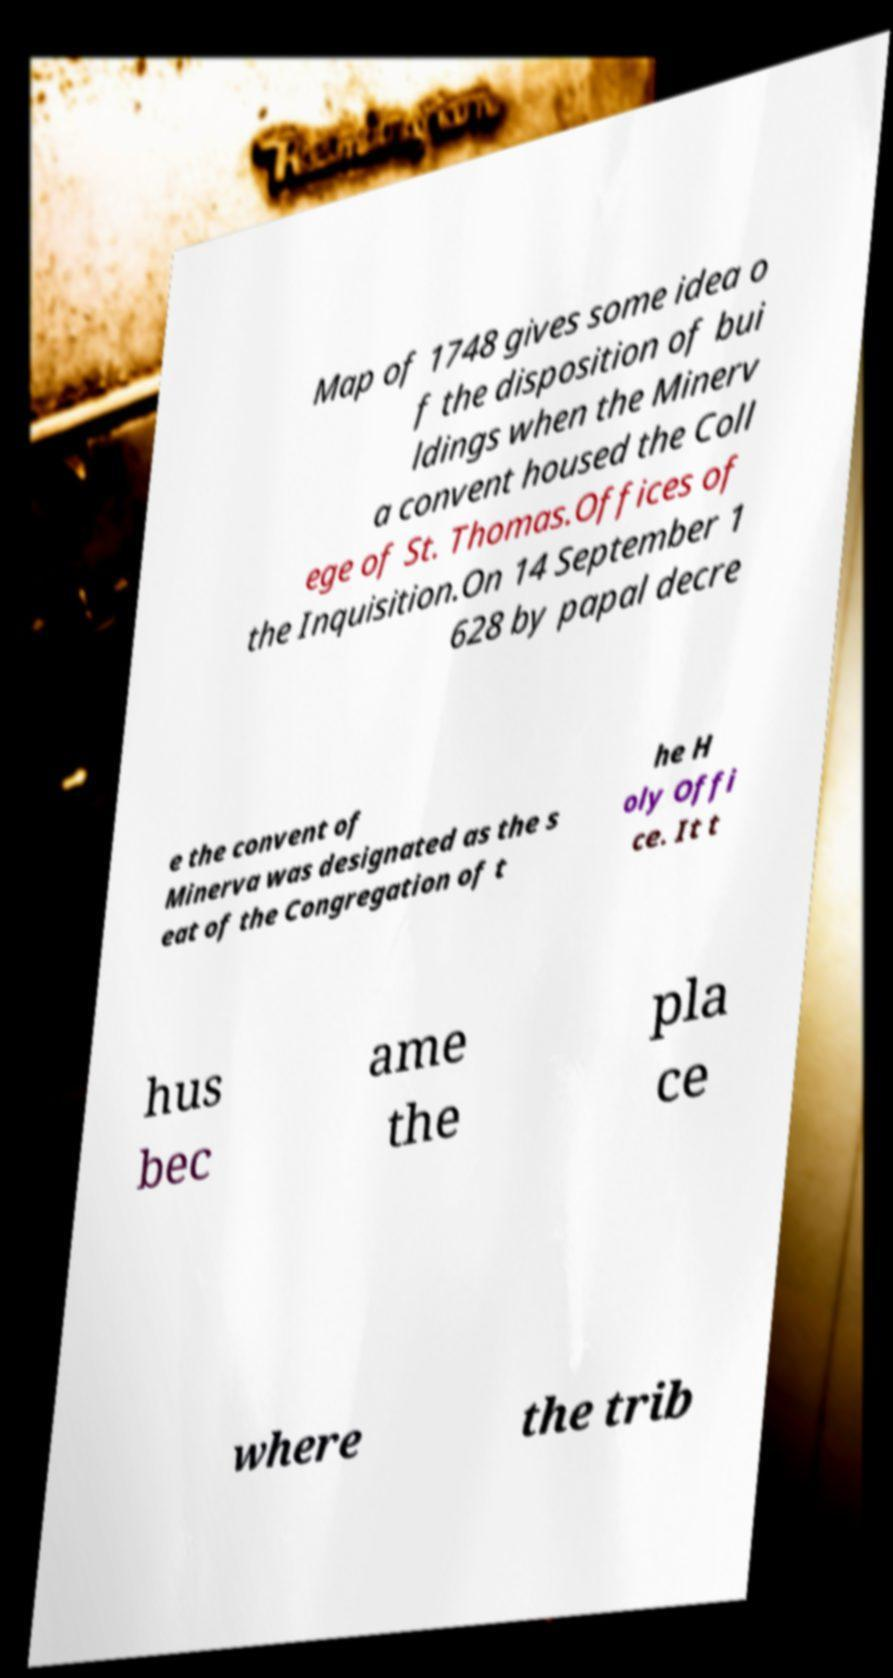I need the written content from this picture converted into text. Can you do that? Map of 1748 gives some idea o f the disposition of bui ldings when the Minerv a convent housed the Coll ege of St. Thomas.Offices of the Inquisition.On 14 September 1 628 by papal decre e the convent of Minerva was designated as the s eat of the Congregation of t he H oly Offi ce. It t hus bec ame the pla ce where the trib 